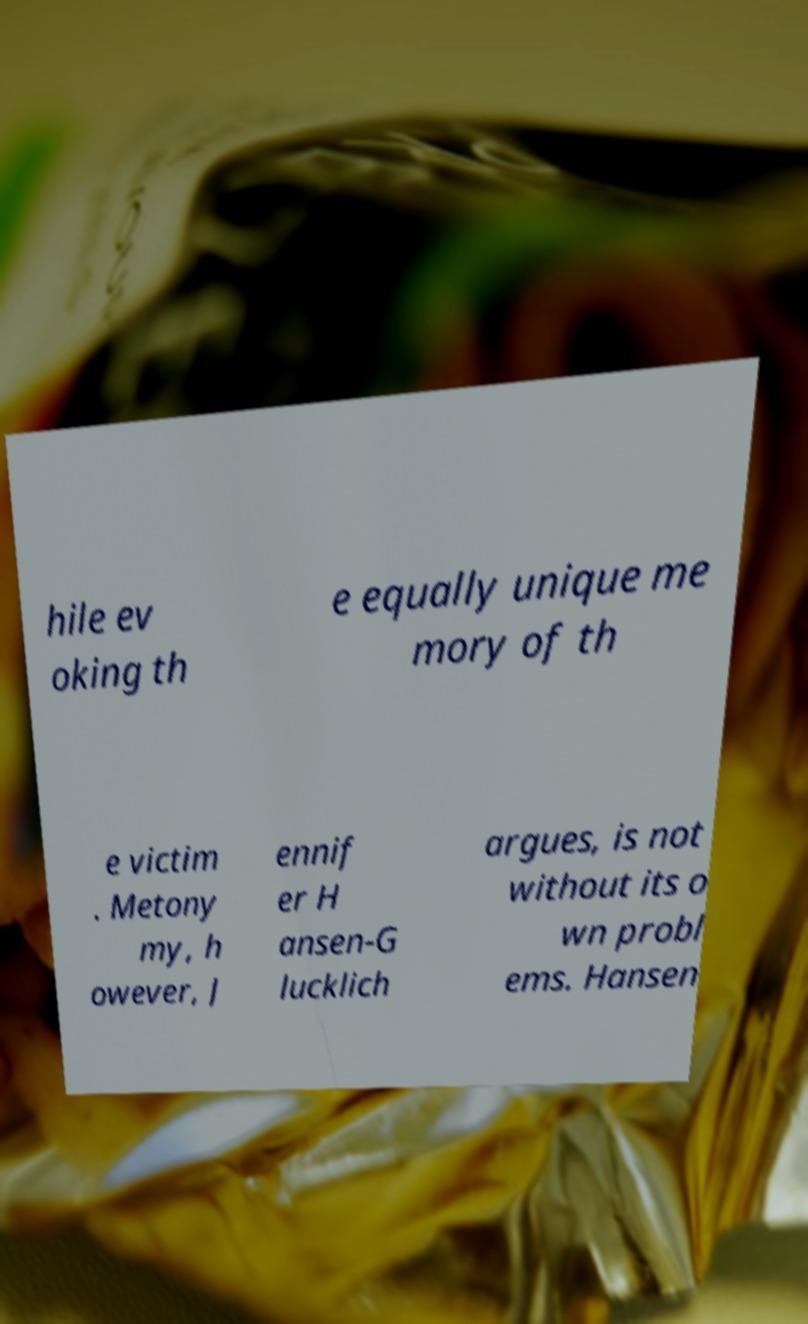I need the written content from this picture converted into text. Can you do that? hile ev oking th e equally unique me mory of th e victim . Metony my, h owever, J ennif er H ansen-G lucklich argues, is not without its o wn probl ems. Hansen 